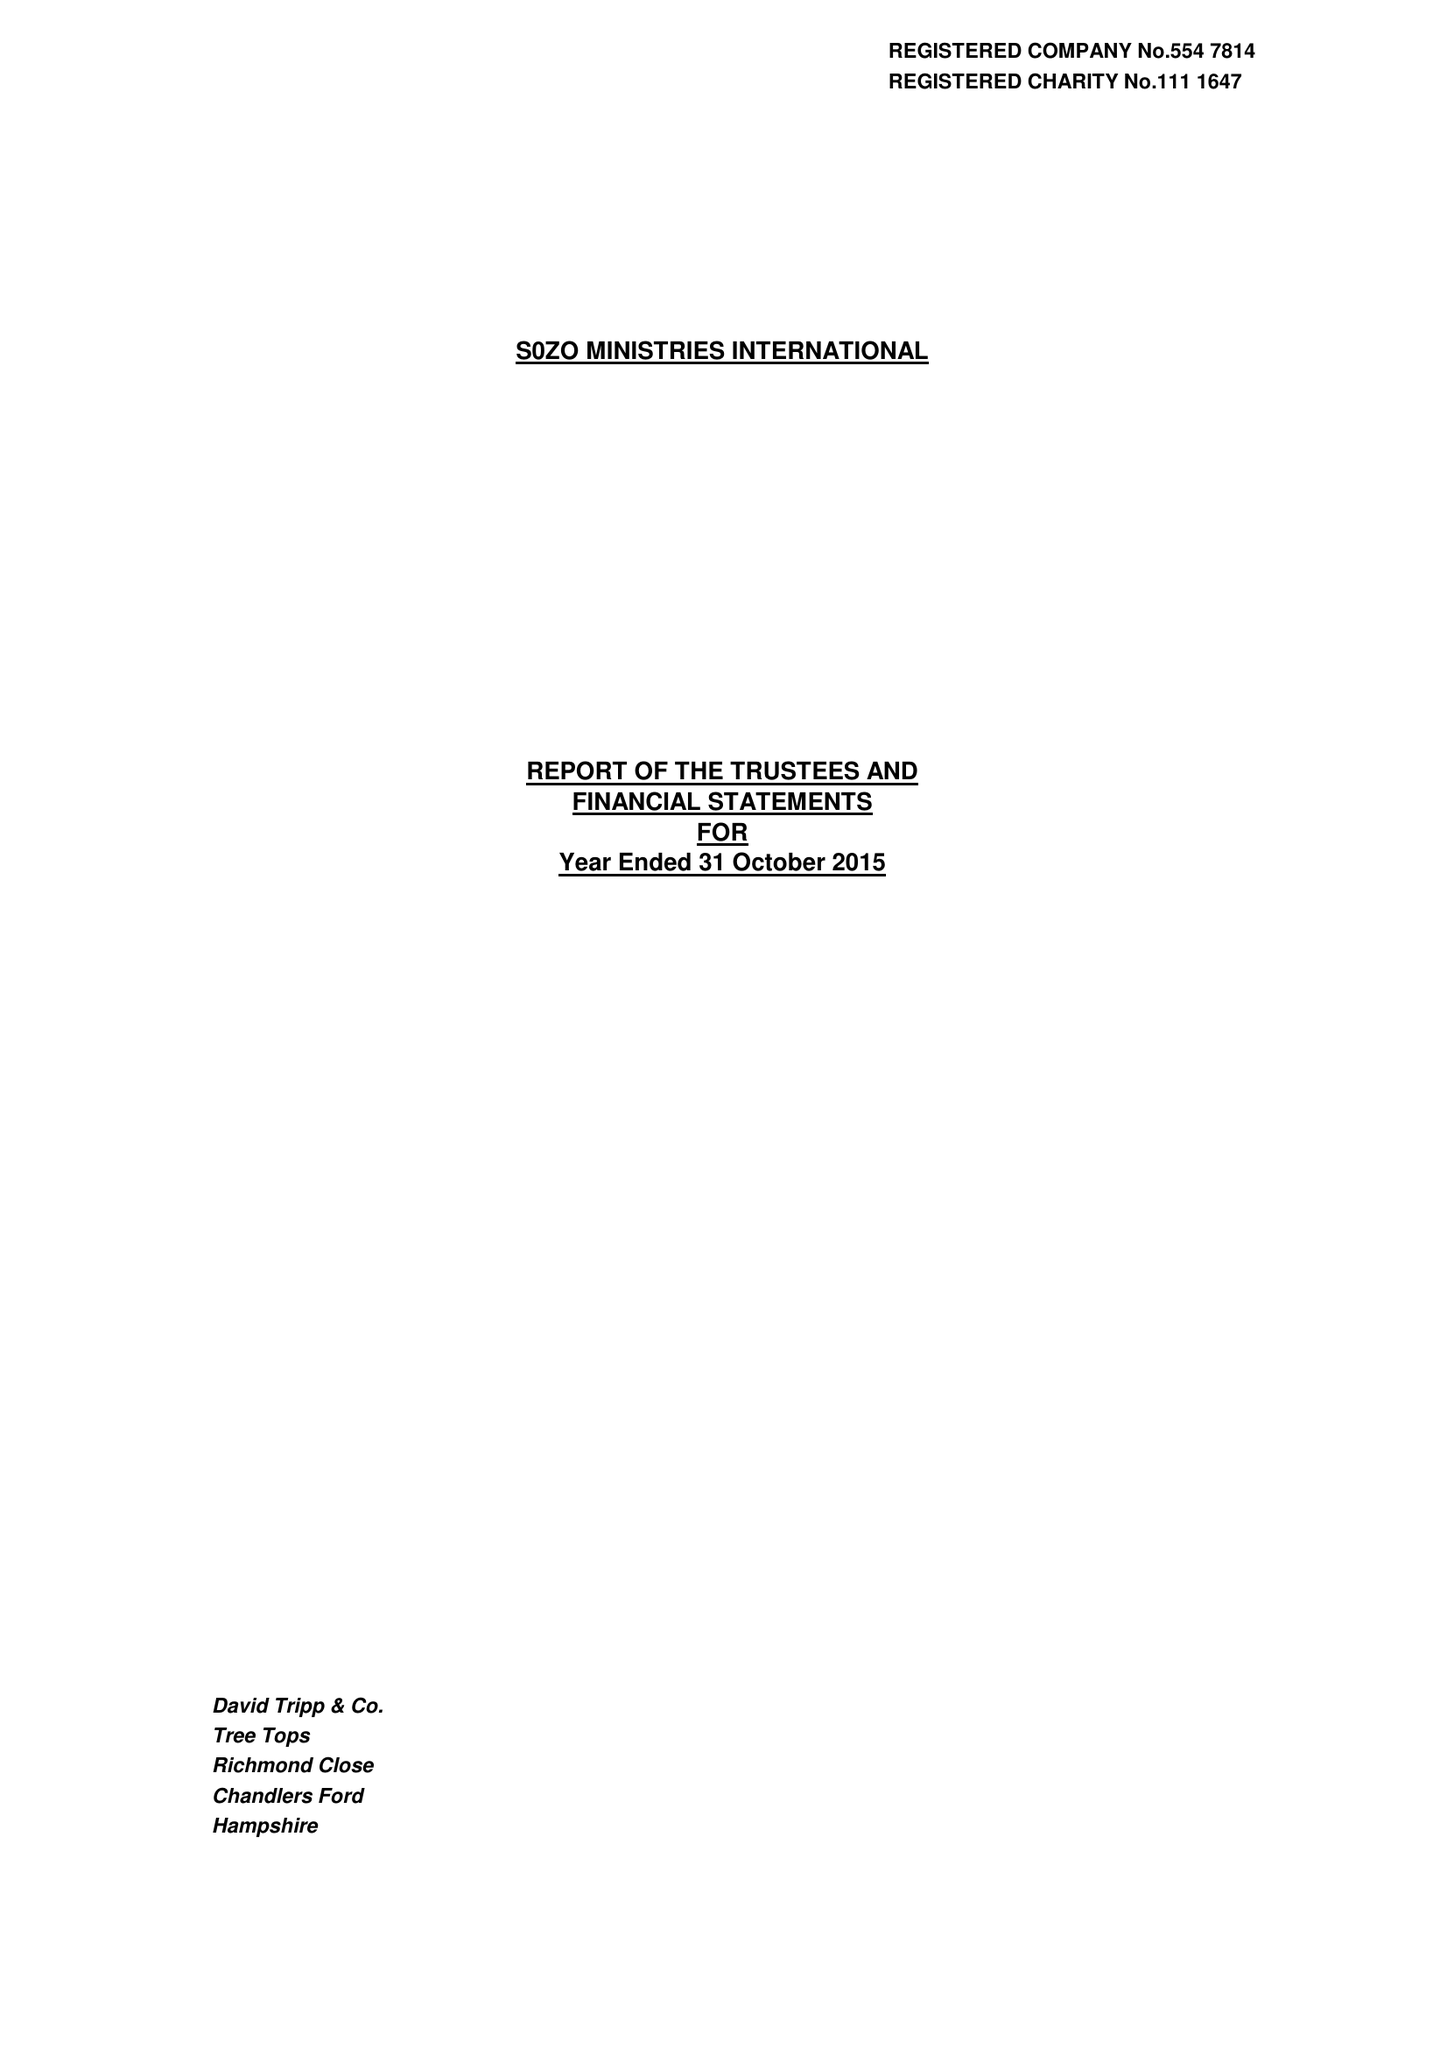What is the value for the income_annually_in_british_pounds?
Answer the question using a single word or phrase. 357365.00 